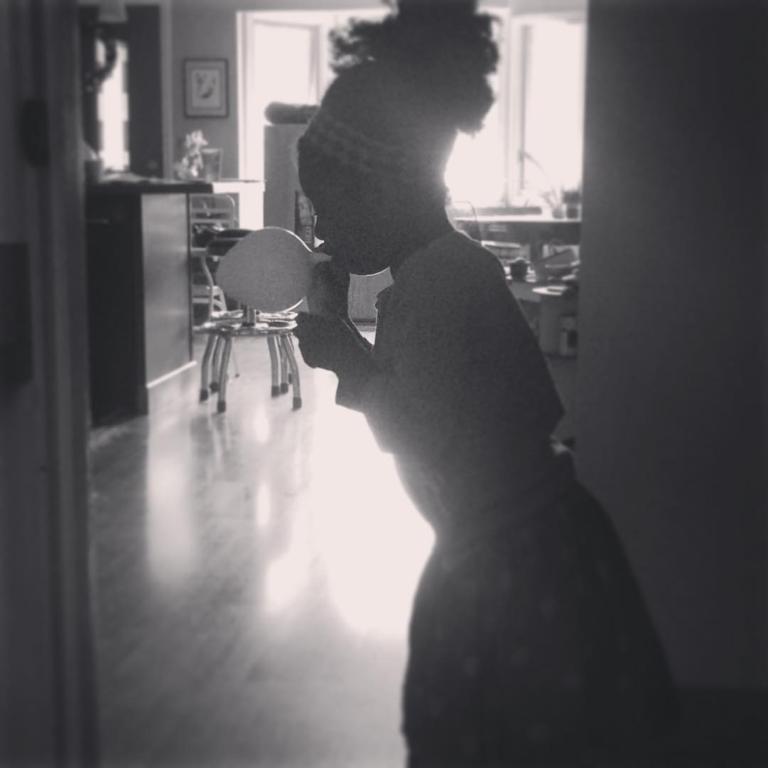How would you summarize this image in a sentence or two? In this picture there is a woman who is standing and blowing a balloon. There is a chair , desk and few objects. There is a frame on the wall. 